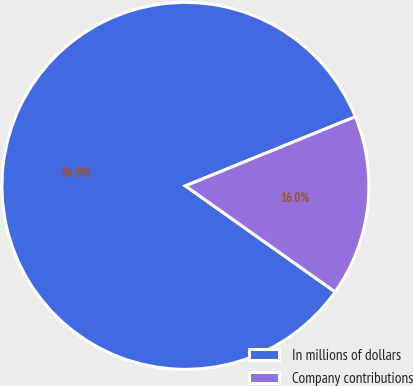Convert chart to OTSL. <chart><loc_0><loc_0><loc_500><loc_500><pie_chart><fcel>In millions of dollars<fcel>Company contributions<nl><fcel>84.04%<fcel>15.96%<nl></chart> 